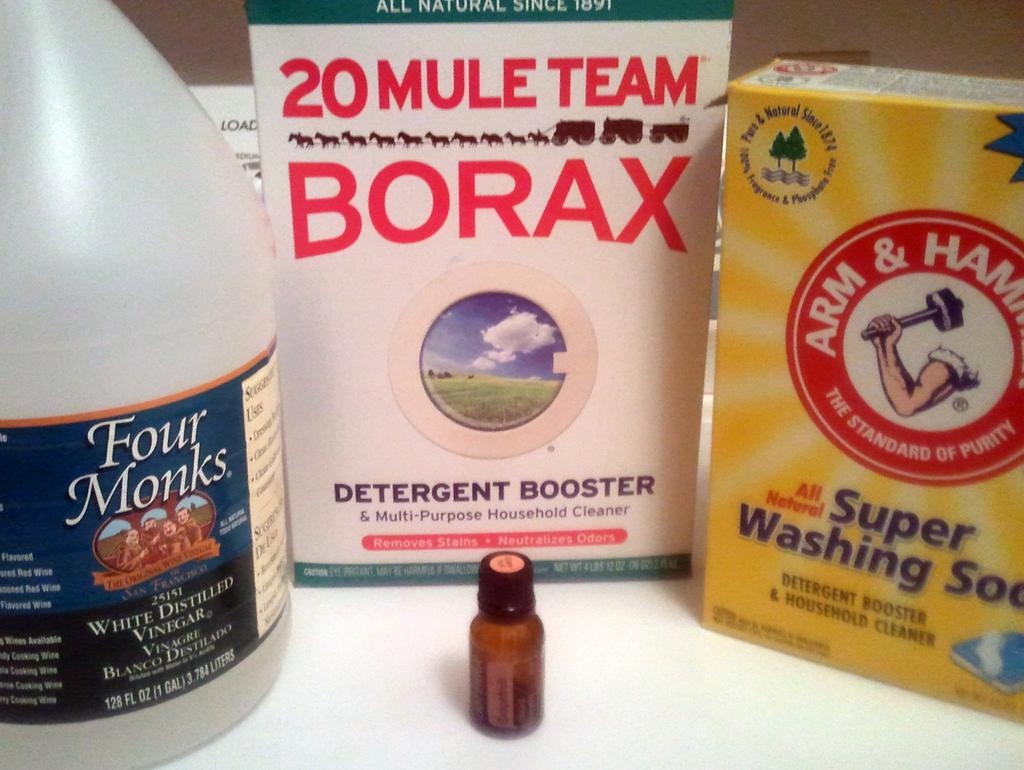Provide a one-sentence caption for the provided image. Washing detergent, one of which is from Arm and Hammer. 